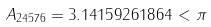<formula> <loc_0><loc_0><loc_500><loc_500>A _ { 2 4 5 7 6 } = 3 . 1 4 1 5 9 2 6 1 8 6 4 < \pi</formula> 